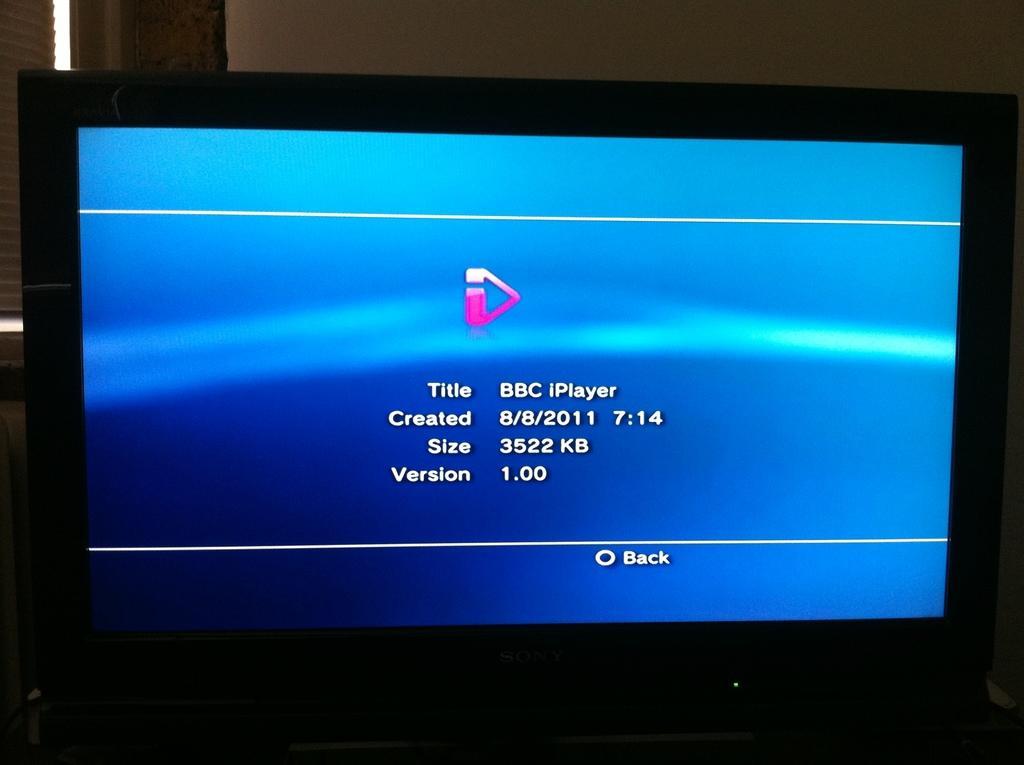Describe this image in one or two sentences. In this image there is a monitor. On the monitor there is some text. In the background there is a wall. 